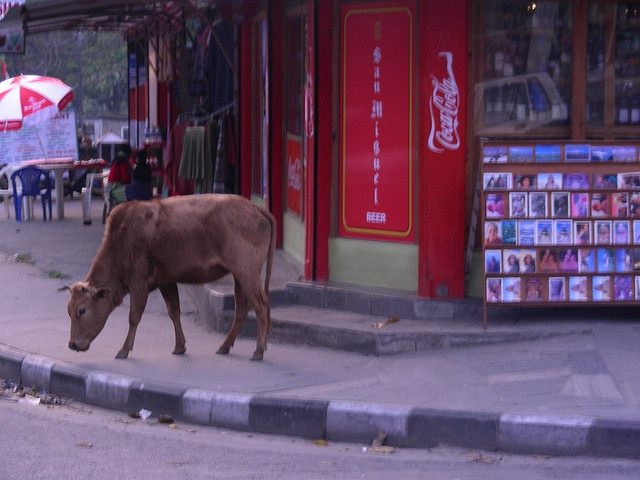Describe the objects in this image and their specific colors. I can see cow in violet, black, and brown tones, umbrella in violet and lavender tones, chair in violet, navy, gray, black, and purple tones, dining table in violet, purple, and gray tones, and people in violet, black, gray, and purple tones in this image. 